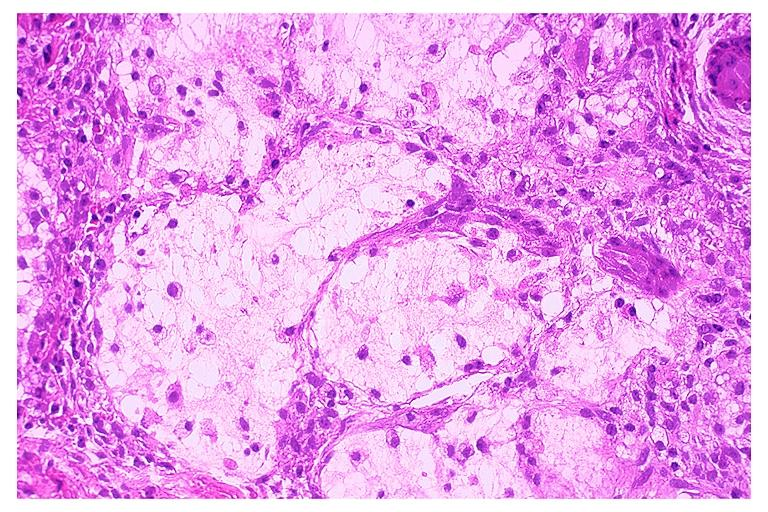what is present?
Answer the question using a single word or phrase. Oral 